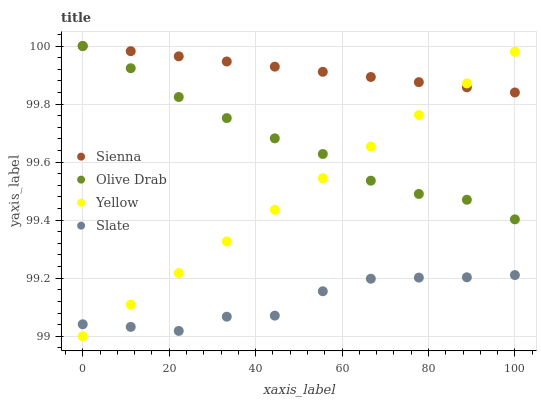Does Slate have the minimum area under the curve?
Answer yes or no. Yes. Does Sienna have the maximum area under the curve?
Answer yes or no. Yes. Does Yellow have the minimum area under the curve?
Answer yes or no. No. Does Yellow have the maximum area under the curve?
Answer yes or no. No. Is Sienna the smoothest?
Answer yes or no. Yes. Is Slate the roughest?
Answer yes or no. Yes. Is Yellow the smoothest?
Answer yes or no. No. Is Yellow the roughest?
Answer yes or no. No. Does Yellow have the lowest value?
Answer yes or no. Yes. Does Slate have the lowest value?
Answer yes or no. No. Does Olive Drab have the highest value?
Answer yes or no. Yes. Does Yellow have the highest value?
Answer yes or no. No. Is Slate less than Sienna?
Answer yes or no. Yes. Is Olive Drab greater than Slate?
Answer yes or no. Yes. Does Sienna intersect Olive Drab?
Answer yes or no. Yes. Is Sienna less than Olive Drab?
Answer yes or no. No. Is Sienna greater than Olive Drab?
Answer yes or no. No. Does Slate intersect Sienna?
Answer yes or no. No. 